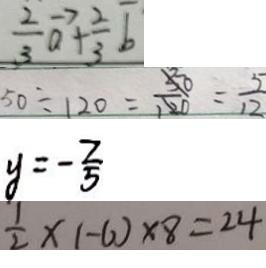<formula> <loc_0><loc_0><loc_500><loc_500>\frac { 2 } { 3 } \overrightarrow { a } + \frac { 2 } { 3 } \overline { b } 
 5 0 \div 1 2 0 = \frac { 5 0 } { 1 2 0 } = \frac { 5 } { 1 2 } 
 y = - \frac { 2 } { 5 } 
 \frac { 1 } { 2 } \times ( - 6 ) \times 8 = 2 4</formula> 